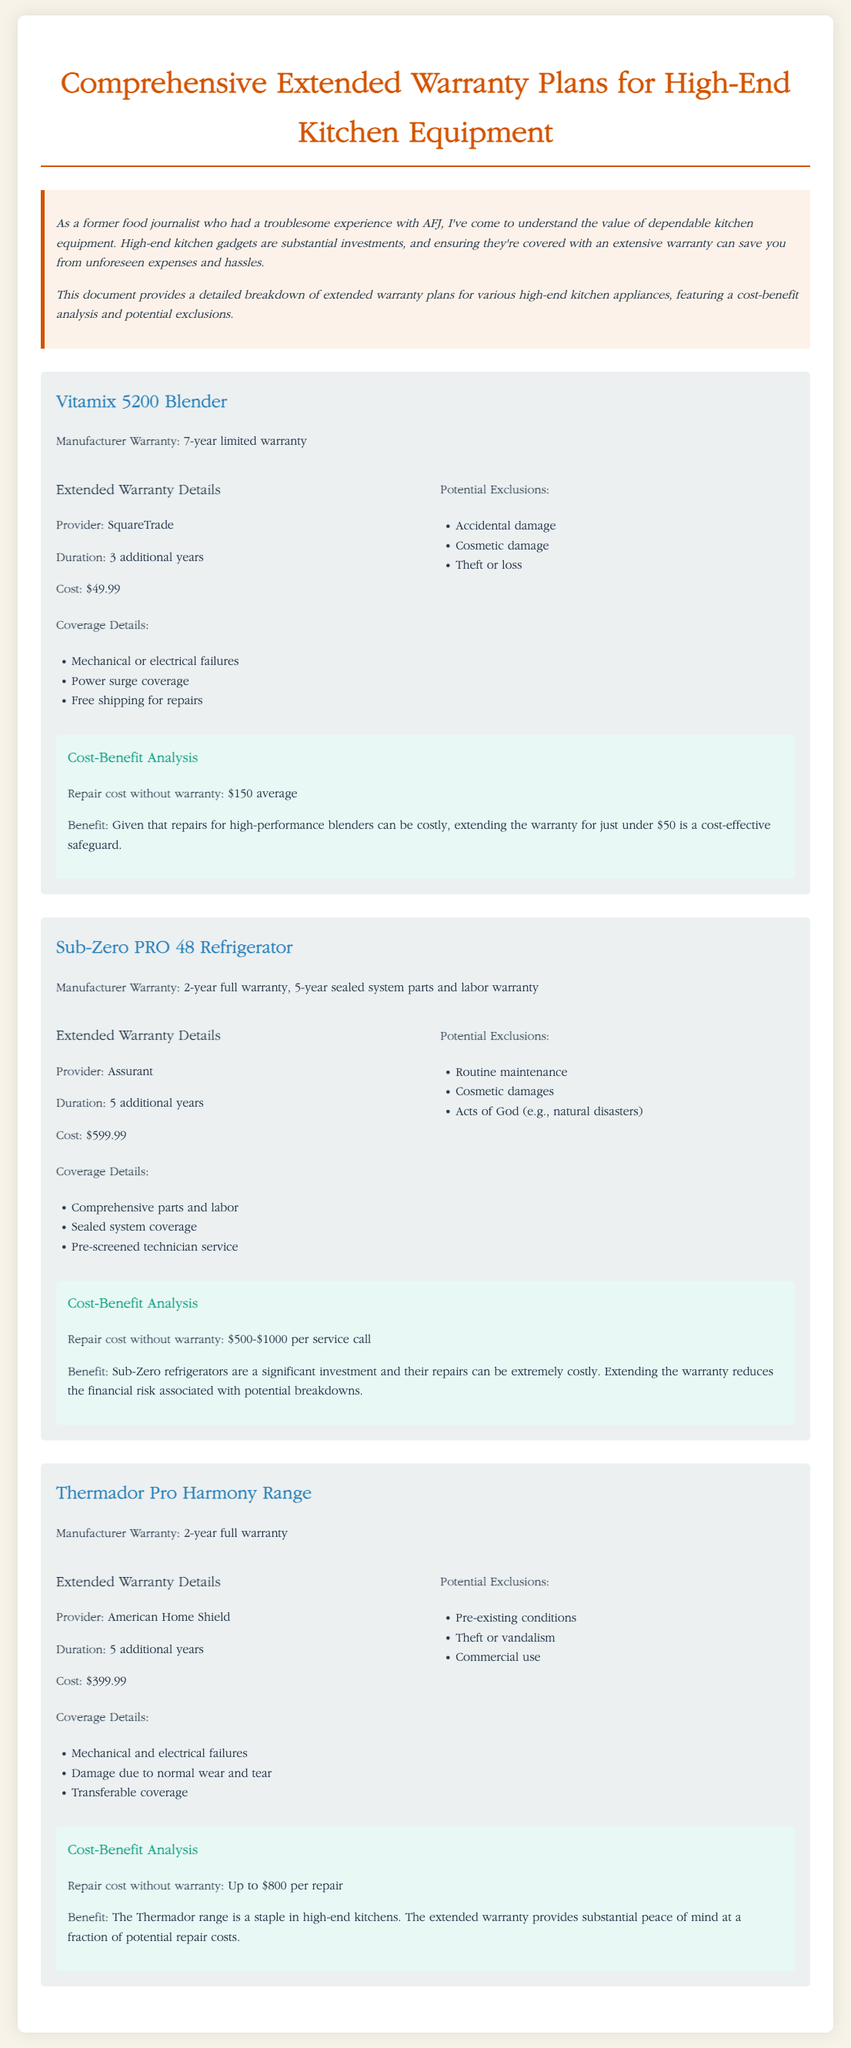What is the manufacturer warranty for the Vitamix 5200 Blender? The manufacturer warranty for the Vitamix 5200 Blender is a 7-year limited warranty.
Answer: 7-year limited warranty How much does the extended warranty for the Sub-Zero PRO 48 Refrigerator cost? The cost of the extended warranty for the Sub-Zero PRO 48 Refrigerator is $599.99.
Answer: $599.99 What is the duration of the extended warranty for the Thermador Pro Harmony Range? The duration of the extended warranty for the Thermador Pro Harmony Range is 5 additional years.
Answer: 5 additional years What type of coverage is included in the extended warranty of the Vitamix 5200 Blender? The extended warranty includes coverage for mechanical or electrical failures, power surge coverage, and free shipping for repairs.
Answer: Mechanical or electrical failures, power surge coverage, free shipping for repairs What is one potential exclusion for the Sub-Zero PRO 48 Refrigerator warranty? One potential exclusion for the Sub-Zero PRO 48 Refrigerator warranty is routine maintenance.
Answer: Routine maintenance Calculate the average repair cost without warranty for the Thermador Pro Harmony Range. The average repair cost without warranty for the Thermador Pro Harmony Range is up to $800 per repair.
Answer: Up to $800 Who is the extended warranty provider for the Vitamix 5200 Blender? The extended warranty provider for the Vitamix 5200 Blender is SquareTrade.
Answer: SquareTrade What benefit do you gain by extending the warranty for high-end kitchen appliances? Extending the warranty reduces the financial risk associated with potential breakdowns.
Answer: Reduces financial risk 